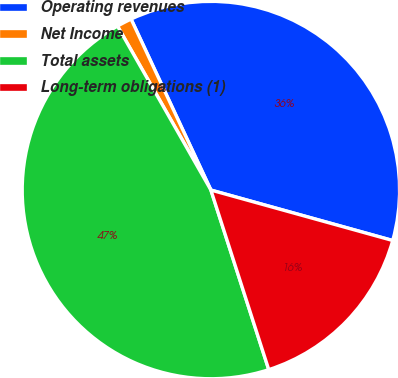<chart> <loc_0><loc_0><loc_500><loc_500><pie_chart><fcel>Operating revenues<fcel>Net Income<fcel>Total assets<fcel>Long-term obligations (1)<nl><fcel>36.26%<fcel>1.29%<fcel>46.72%<fcel>15.73%<nl></chart> 